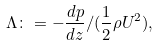Convert formula to latex. <formula><loc_0><loc_0><loc_500><loc_500>\Lambda \colon = - \frac { d p } { d z } / ( \frac { 1 } { 2 } \rho U ^ { 2 } ) ,</formula> 